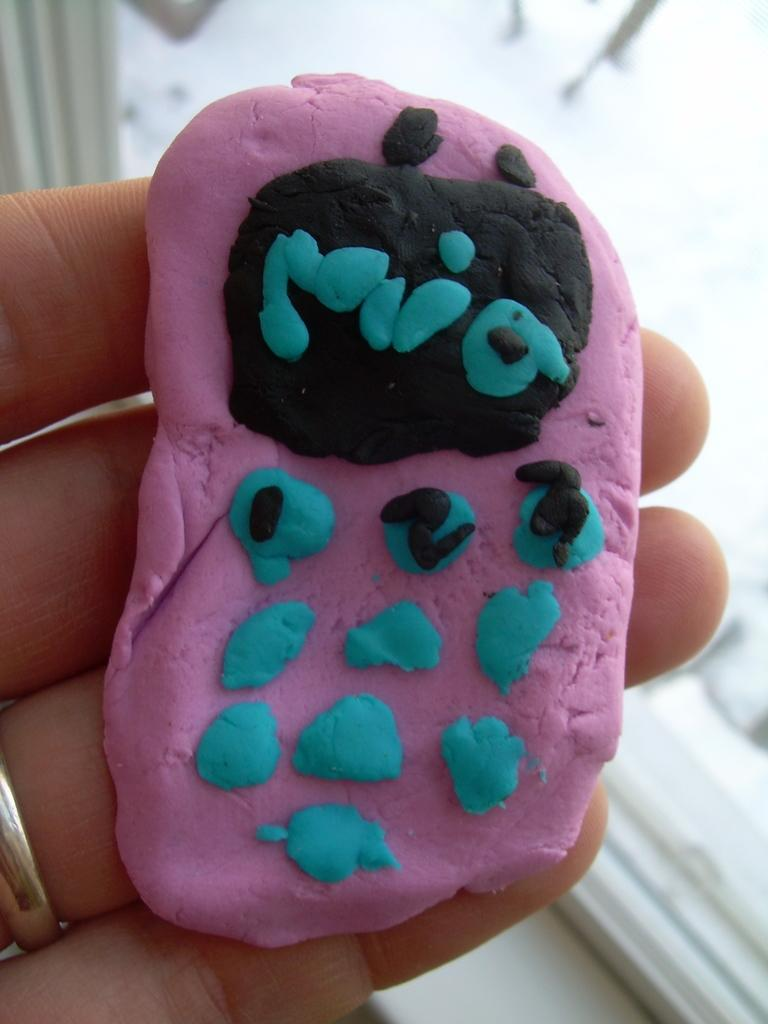What can be seen on the fingers in the image? A ring is on one of the fingers in the image. What is the ring made of? The material of the ring is clay. What else is visible in the background of the image? There is a glass object in the background of the image. Can you see any snails crawling on the ring in the image? No, there are no snails present in the image. Are there any dinosaurs visible in the image? No, there are no dinosaurs present in the image. 